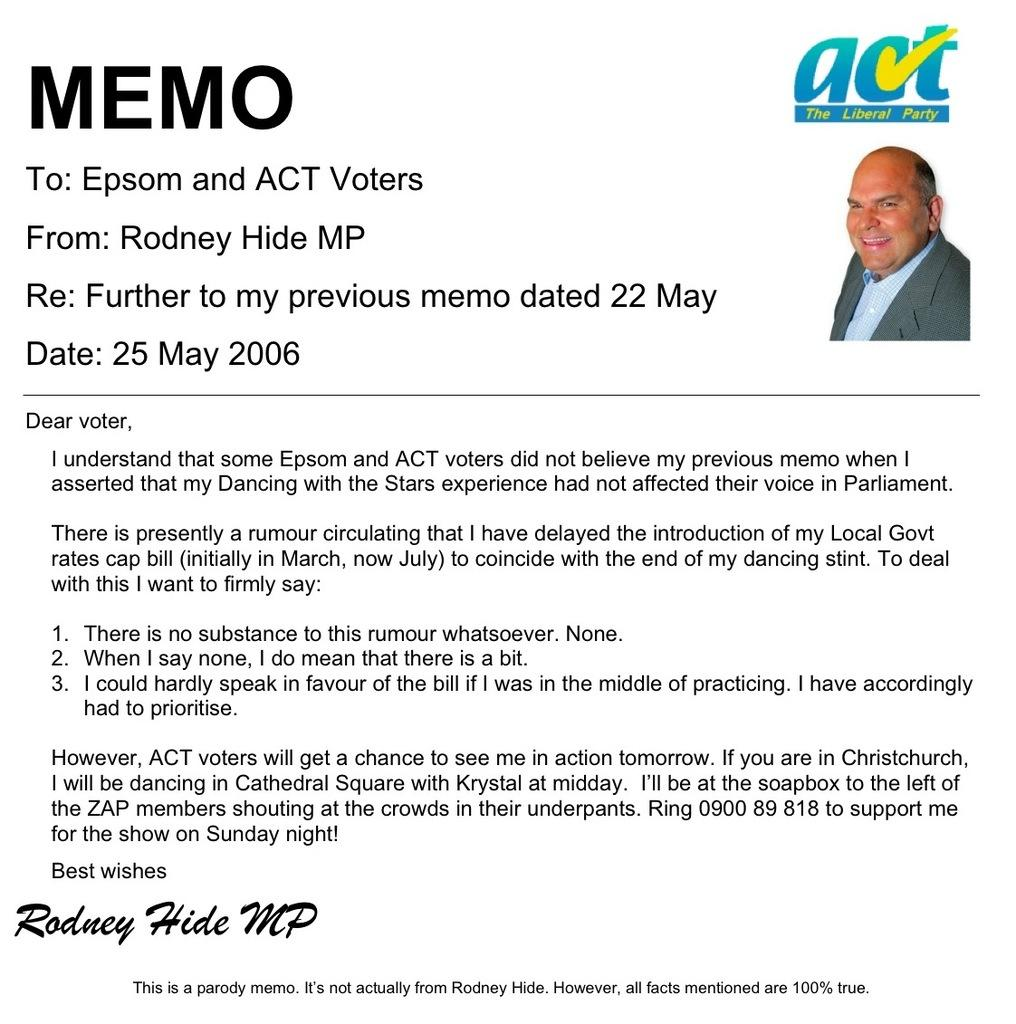What is the main feature in the middle of the image? There is text in the middle of the image. What can be seen on the right side of the image? There is an image of a man on the right side of the image. What type of scarecrow is standing in the field on the left side of the image? There is no scarecrow or field present in the image; it only contains text and an image of a man. What country is depicted in the image? The image does not depict a specific country; it only contains text and an image of a man. 